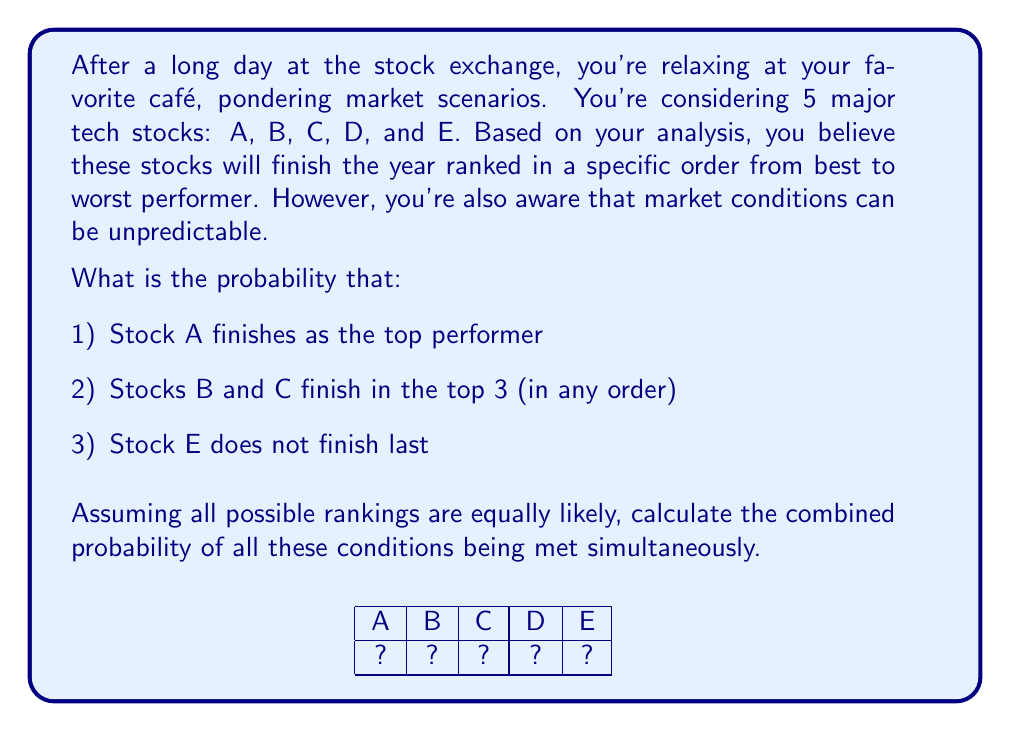Help me with this question. Let's approach this step-by-step:

1) First, we need to calculate the total number of possible permutations. With 5 stocks, we have:
   $$5! = 5 \times 4 \times 3 \times 2 \times 1 = 120$$ total permutations

2) Now, let's consider each condition:

   a) Stock A finishes first:
      There are 4! ways to arrange the other 4 stocks after A.
      $$P(\text{A first}) = \frac{4!}{5!} = \frac{24}{120} = \frac{1}{5}$$

   b) Stocks B and C in top 3 (any order):
      We can have ABC, ACB, BAC, BCA, CAB, CBA as the top 3.
      For each of these, there are 2! ways to arrange the remaining 2 stocks.
      $$P(\text{B and C in top 3}) = \frac{6 \times 2!}{5!} = \frac{12}{120} = \frac{1}{10}$$

   c) Stock E not last:
      This is equivalent to any of the other 4 stocks being last.
      $$P(\text{E not last}) = \frac{4 \times 4!}{5!} = \frac{96}{120} = \frac{4}{5}$$

3) For all these conditions to be met simultaneously, we need to find permutations where:
   - A is first
   - B and C are in the top 3
   - E is not last

   These permutations are: ABCDE, ACBDE

4) Therefore, the probability is:
   $$P(\text{all conditions met}) = \frac{2}{120} = \frac{1}{60}$$
Answer: $\frac{1}{60}$ 